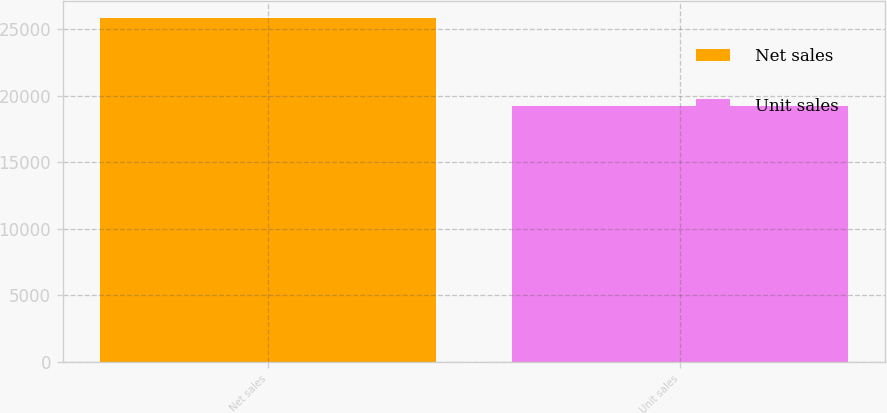Convert chart. <chart><loc_0><loc_0><loc_500><loc_500><bar_chart><fcel>Net sales<fcel>Unit sales<nl><fcel>25850<fcel>19251<nl></chart> 